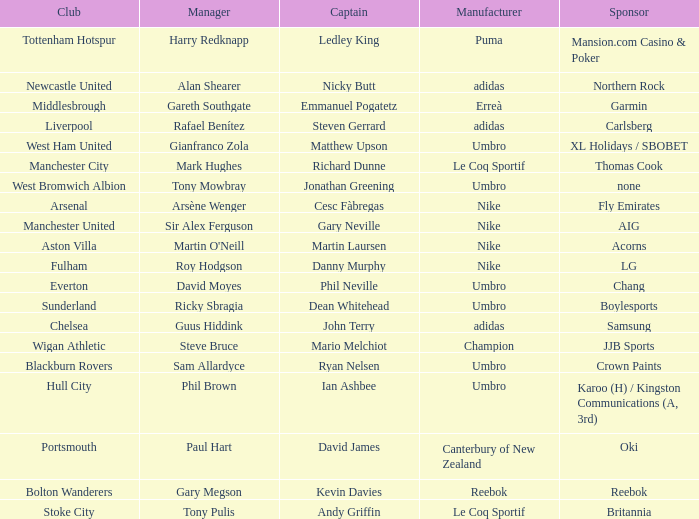Which Manchester United captain is sponsored by Nike? Gary Neville. 